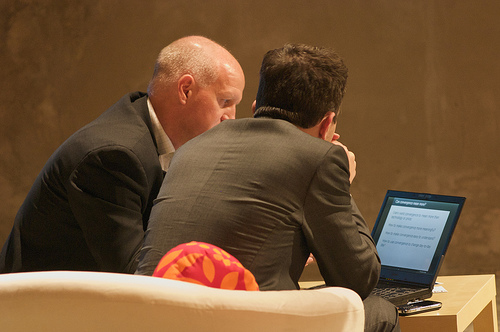What are the two men in the photo doing? The two men appear to be engaged in a close and serious conversation, one is showing the other something on a laptop screen. 